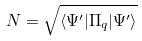<formula> <loc_0><loc_0><loc_500><loc_500>N = \sqrt { \langle \Psi ^ { \prime } | \Pi _ { q } | \Psi ^ { \prime } \rangle }</formula> 